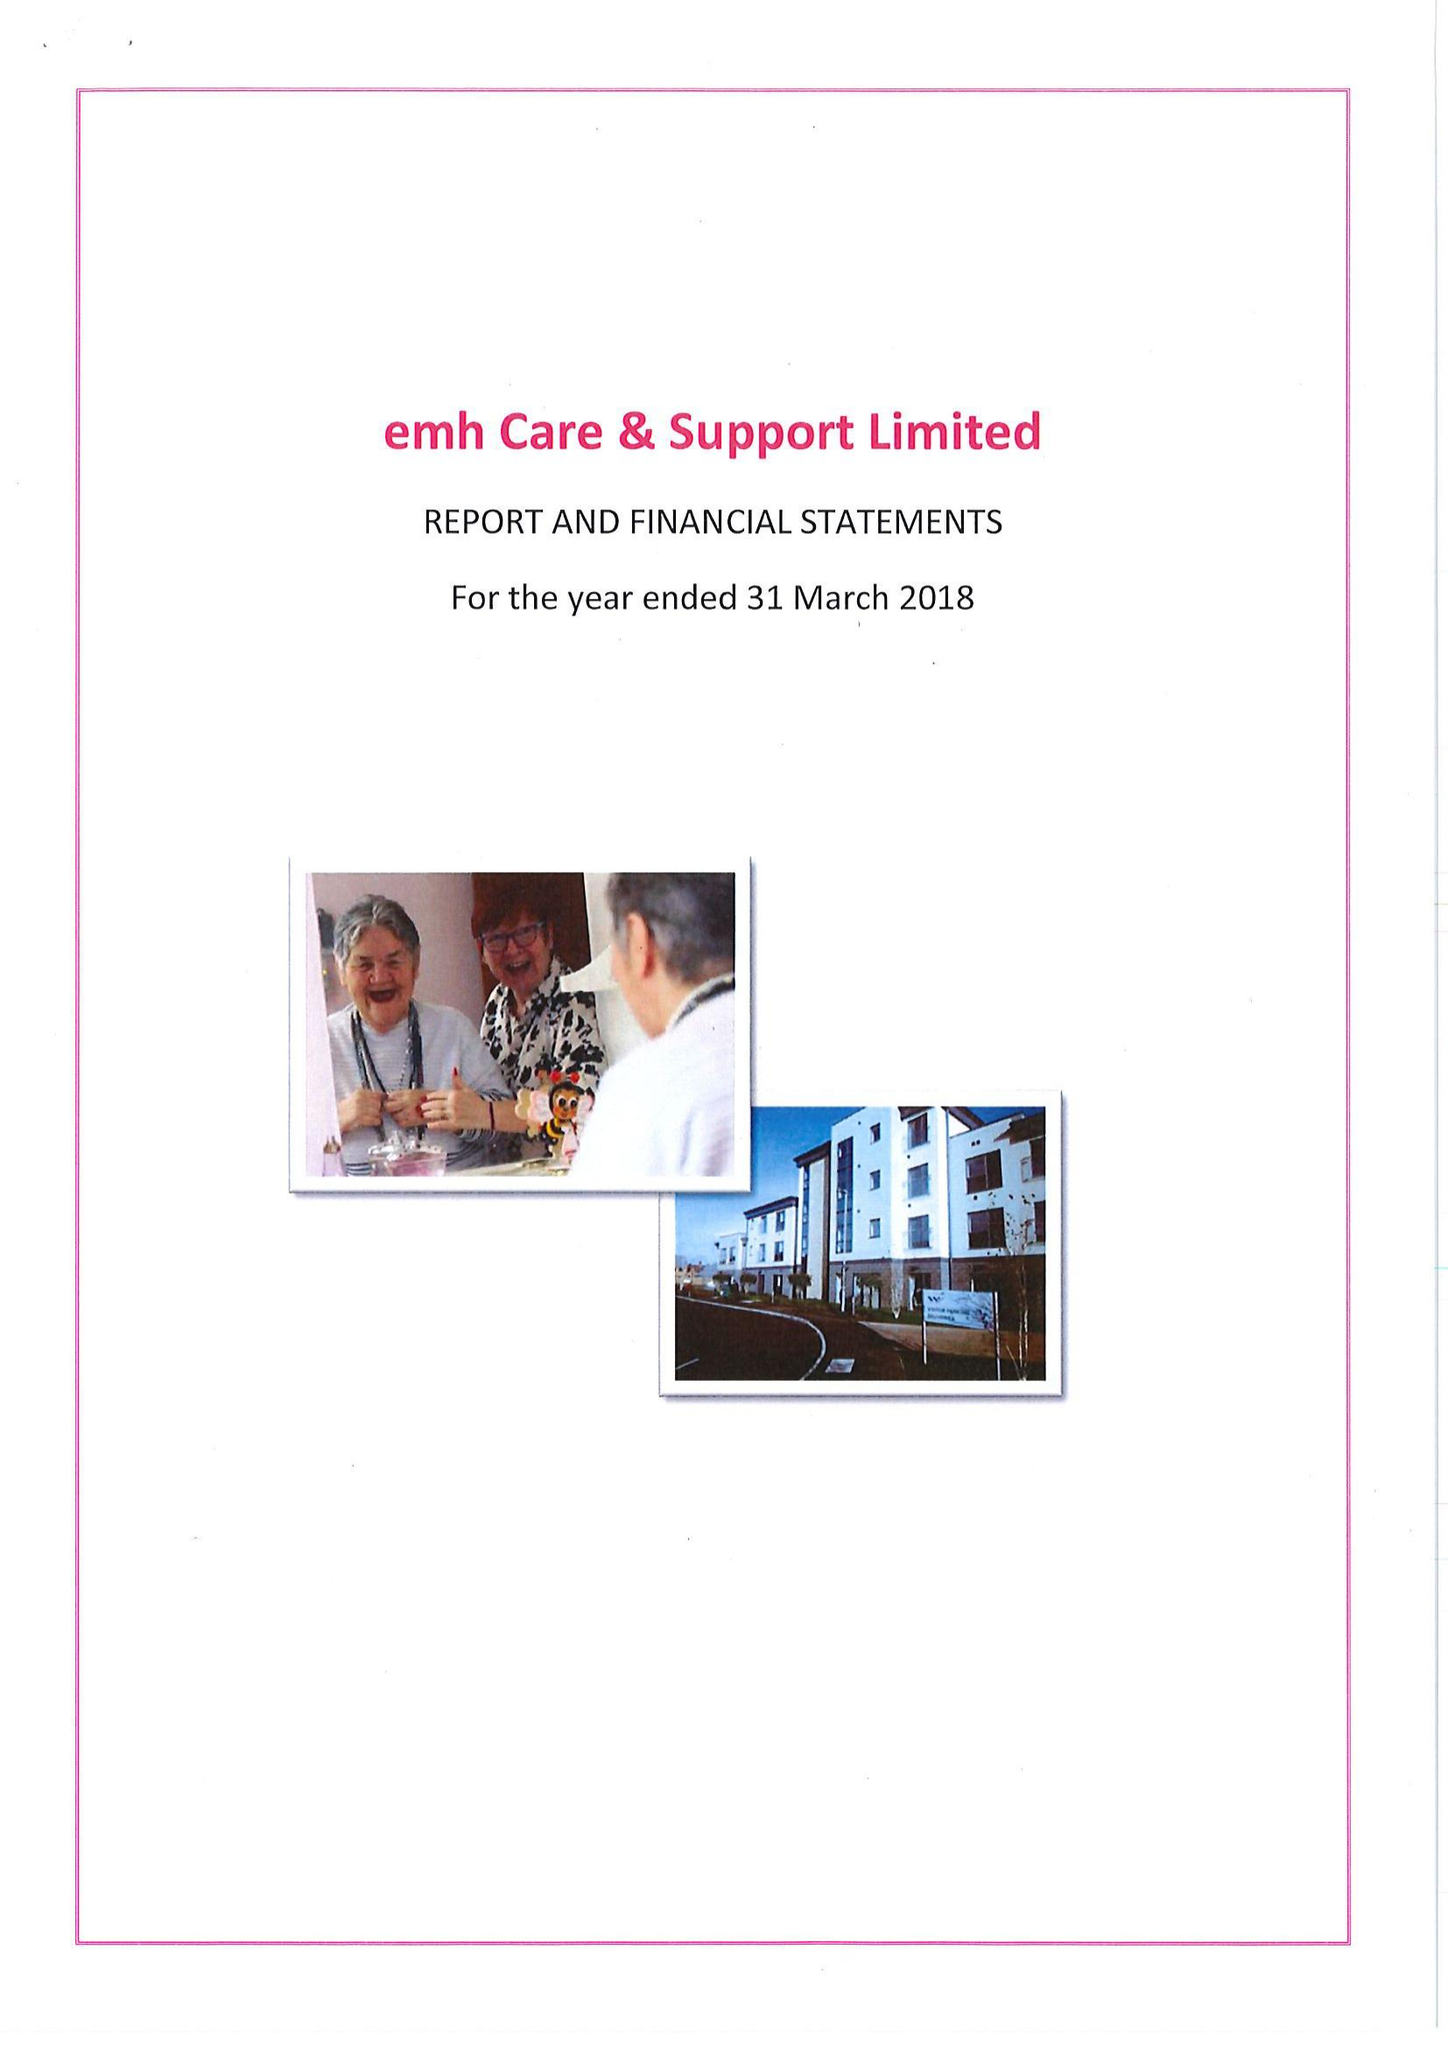What is the value for the address__street_line?
Answer the question using a single word or phrase. STENSON ROAD 